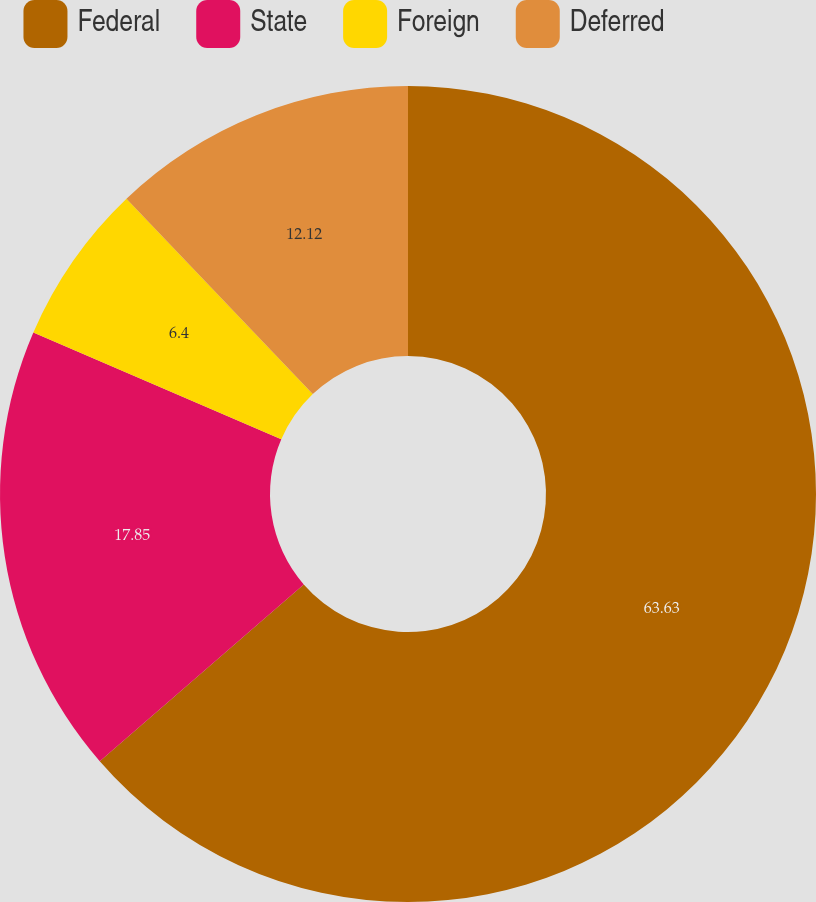<chart> <loc_0><loc_0><loc_500><loc_500><pie_chart><fcel>Federal<fcel>State<fcel>Foreign<fcel>Deferred<nl><fcel>63.63%<fcel>17.85%<fcel>6.4%<fcel>12.12%<nl></chart> 